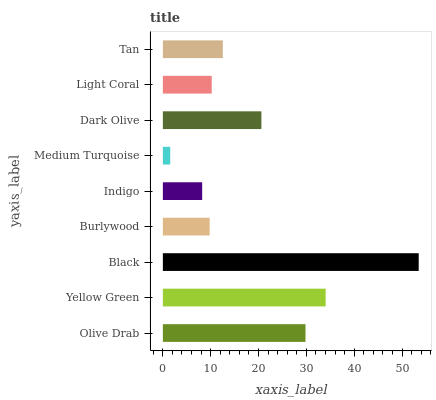Is Medium Turquoise the minimum?
Answer yes or no. Yes. Is Black the maximum?
Answer yes or no. Yes. Is Yellow Green the minimum?
Answer yes or no. No. Is Yellow Green the maximum?
Answer yes or no. No. Is Yellow Green greater than Olive Drab?
Answer yes or no. Yes. Is Olive Drab less than Yellow Green?
Answer yes or no. Yes. Is Olive Drab greater than Yellow Green?
Answer yes or no. No. Is Yellow Green less than Olive Drab?
Answer yes or no. No. Is Tan the high median?
Answer yes or no. Yes. Is Tan the low median?
Answer yes or no. Yes. Is Light Coral the high median?
Answer yes or no. No. Is Dark Olive the low median?
Answer yes or no. No. 